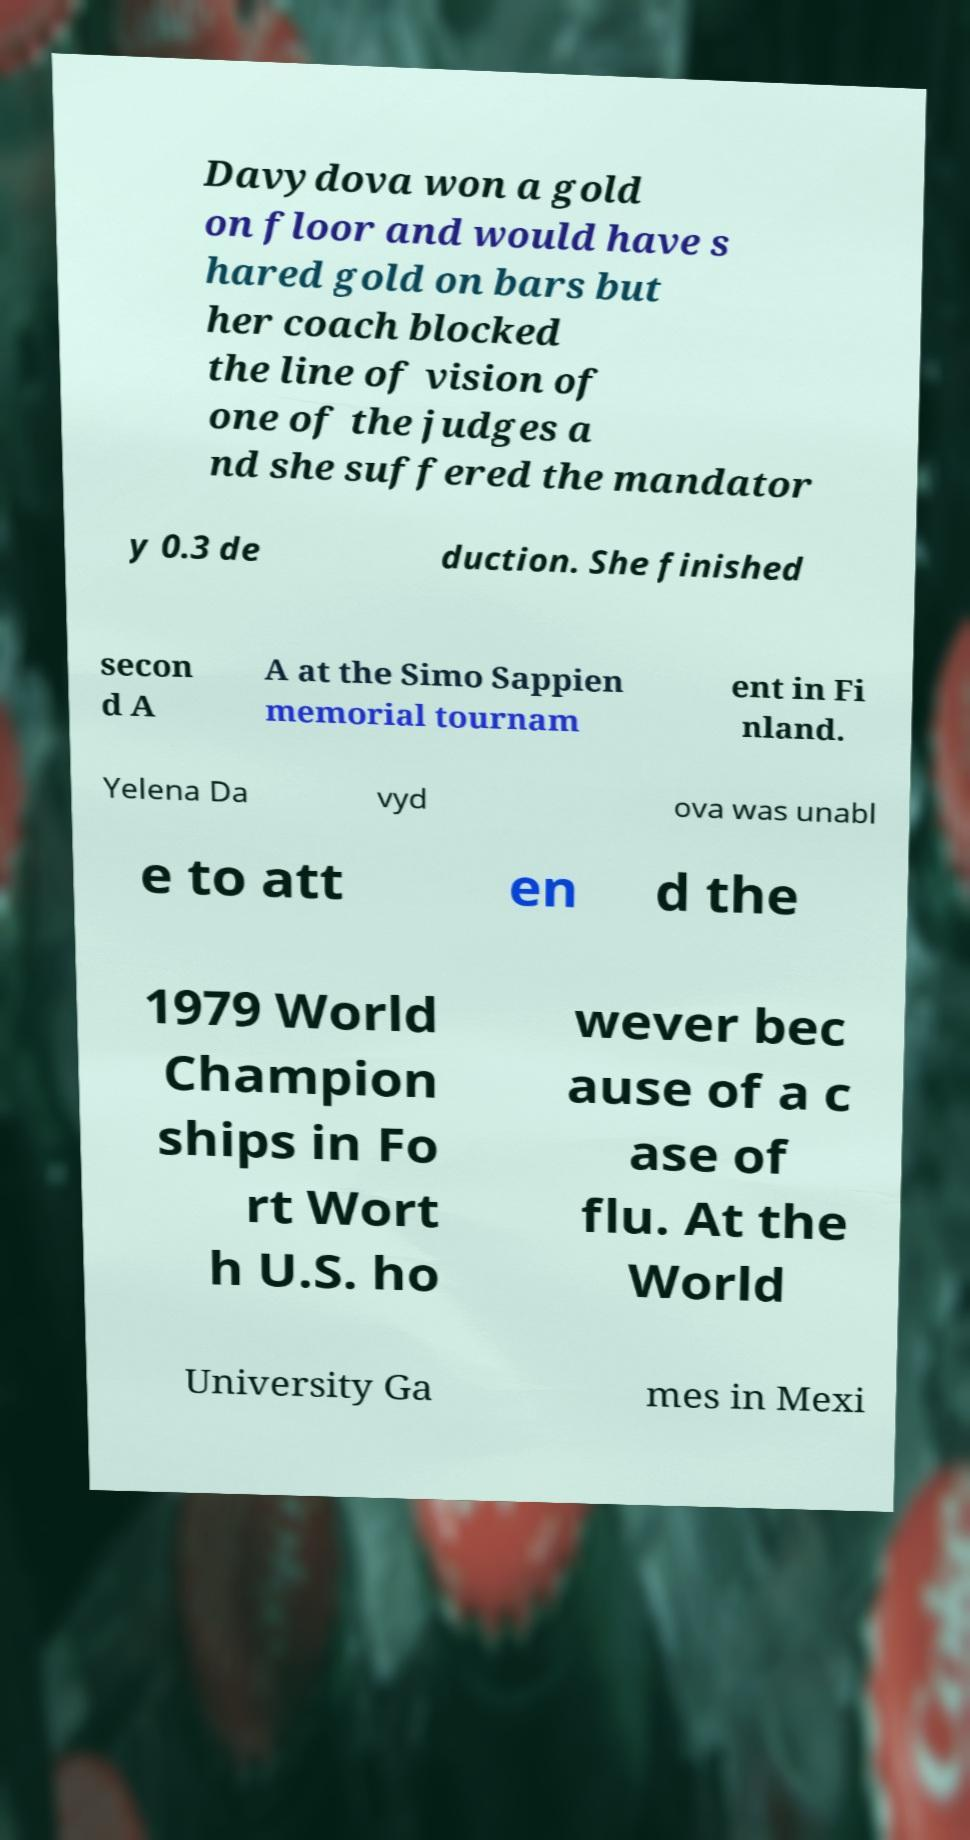What messages or text are displayed in this image? I need them in a readable, typed format. Davydova won a gold on floor and would have s hared gold on bars but her coach blocked the line of vision of one of the judges a nd she suffered the mandator y 0.3 de duction. She finished secon d A A at the Simo Sappien memorial tournam ent in Fi nland. Yelena Da vyd ova was unabl e to att en d the 1979 World Champion ships in Fo rt Wort h U.S. ho wever bec ause of a c ase of flu. At the World University Ga mes in Mexi 